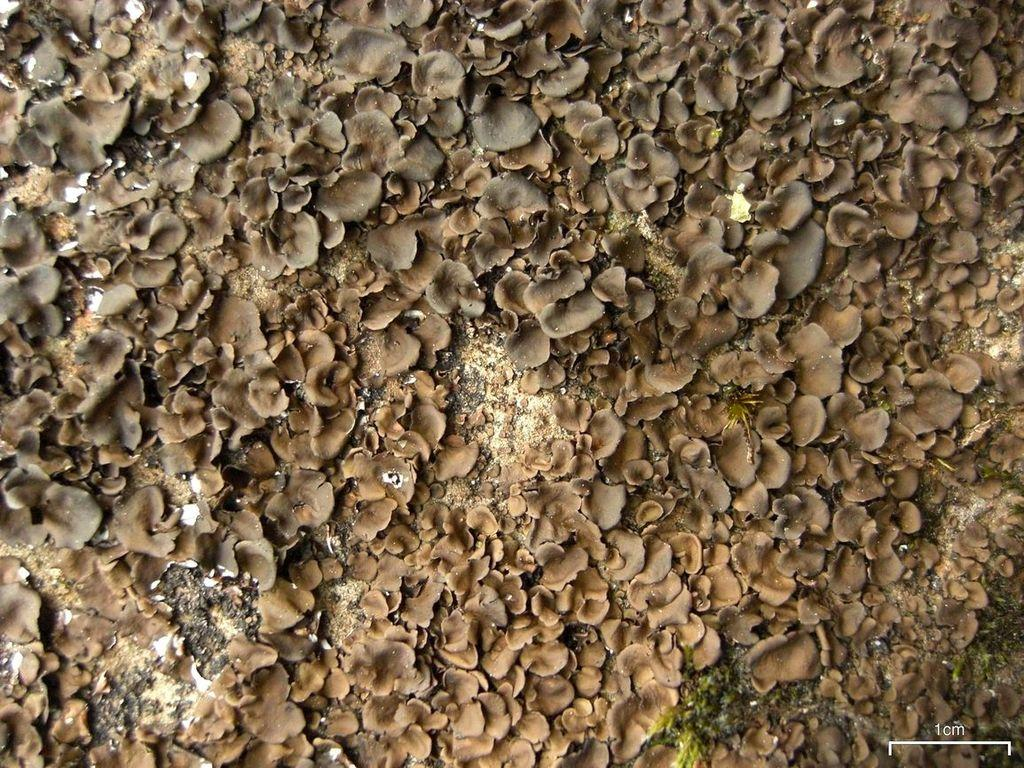What objects in the image resemble planets? There are objects in the image that resemble planets. Where are these planet-like objects placed? These objects are placed on the ground. How many legs can be seen on the planet-like objects in the image? The planet-like objects in the image do not have legs, as they are not living creatures. Is there a volcano visible in the image? There is no volcano present in the image; it only features objects that resemble planets. 